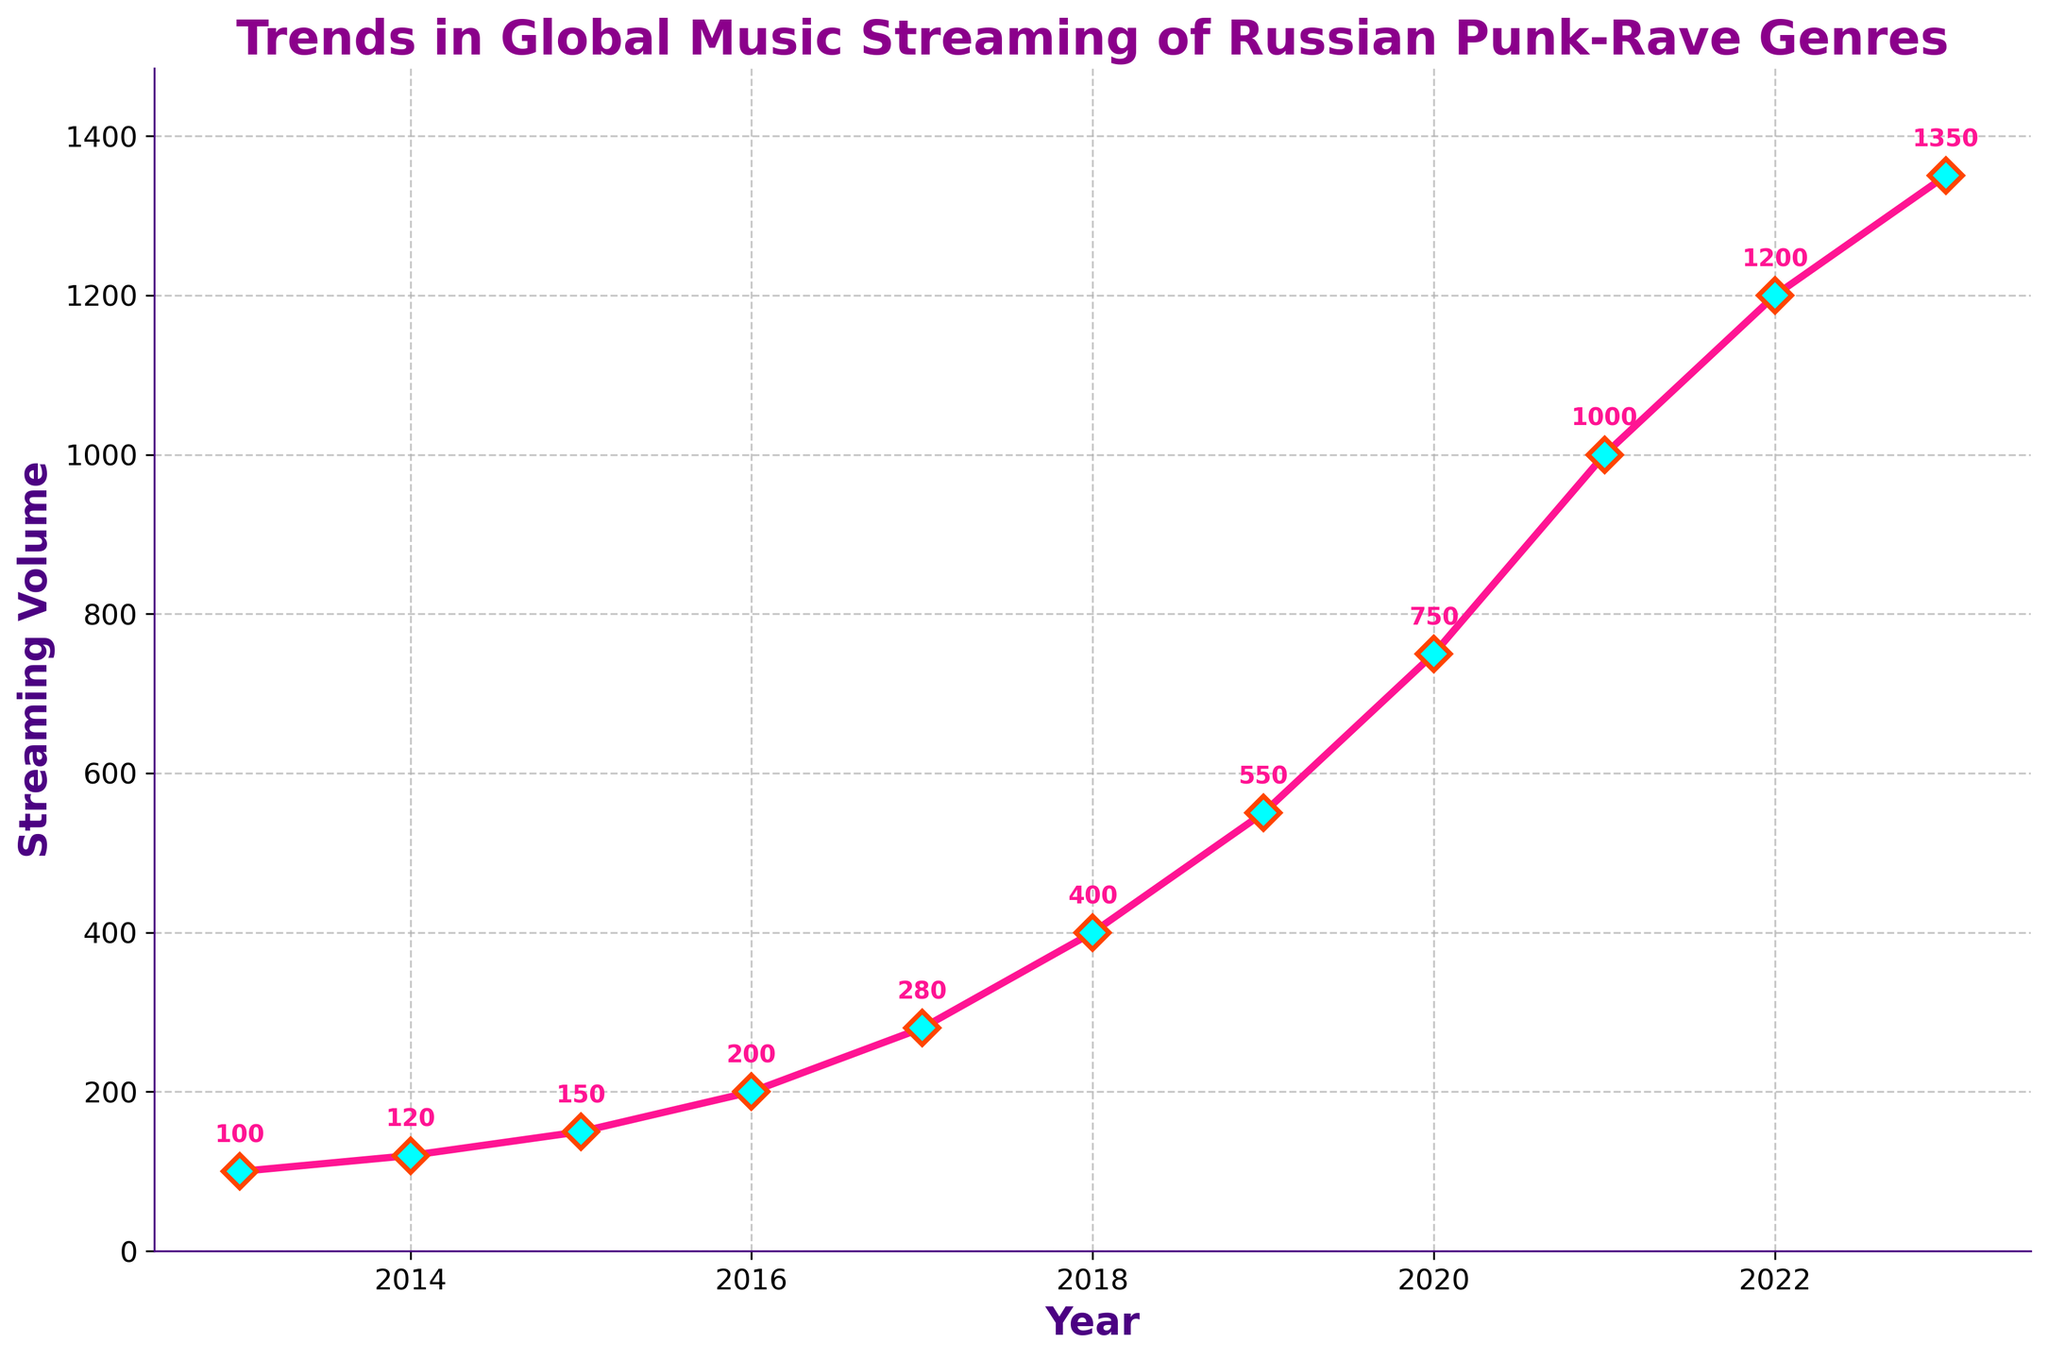What is the highest streaming volume recorded in the chart? The highest streaming volume is identified at the peak point on the graph. It occurs in the year 2023 with a value of 1350.
Answer: 1350 Which year showed the greatest increase in streaming volume compared to the previous year? To determine the greatest increase, calculate the difference in streaming volume between each consecutive year and identify the largest. The years to compare are 2019 to 2020, showing an increase from 550 to 750, a difference of 200.
Answer: 2019 to 2020 What is the average streaming volume over the decade? To find the average, sum the streaming volumes from 2013 to 2023 and divide by the number of years. The sum is 100 + 120 + 150 + 200 + 280 + 400 + 550 + 750 + 1000 + 1200 + 1350 = 6100. There are 11 years. Hence, the average is 6100 / 11 ≈ 554.55.
Answer: 554.55 In which year did the streaming volume first exceed 500? By examining the graph, the streaming volume first exceeds 500 in the year 2019 with a streaming volume of 550.
Answer: 2019 How does the streaming volume in 2017 compare to that in 2022? To compare, look at the volumes for 2017 and 2022. In 2017, the volume is 280, and in 2022, it is 1200. Therefore, the streaming volume in 2022 is significantly higher than in 2017.
Answer: Higher in 2022 What is the median streaming volume over the decade, and how is it calculated? To find the median, list the streaming volumes in ascending order. The middle value in this ordered list is the median. Ordered volumes: 100, 120, 150, 200, 280, 400, 550, 750, 1000, 1200, 1350. The median value is 400 (the 6th value in the ordered list).
Answer: 400 By how much did the streaming volume change from 2015 to 2021? Calculate the change in streaming volume by subtracting the volume in 2015 from the volume in 2021: 1000 - 150 = 850.
Answer: 850 Describe the visual style of the plot, particularly focusing on the visual characteristics of the data points and lines. The plot features magenta-colored lines with diamond-shaped markers. The markers have aqua fill with orange edges, and the titles and labels use bold and varying shades of pink, purple, and indigo. Gridlines are displayed as dashed. Annotations display streaming volumes above each data point.
Answer: Magenta lines, diamond markers, bold titles in bright colors, dashed gridlines 